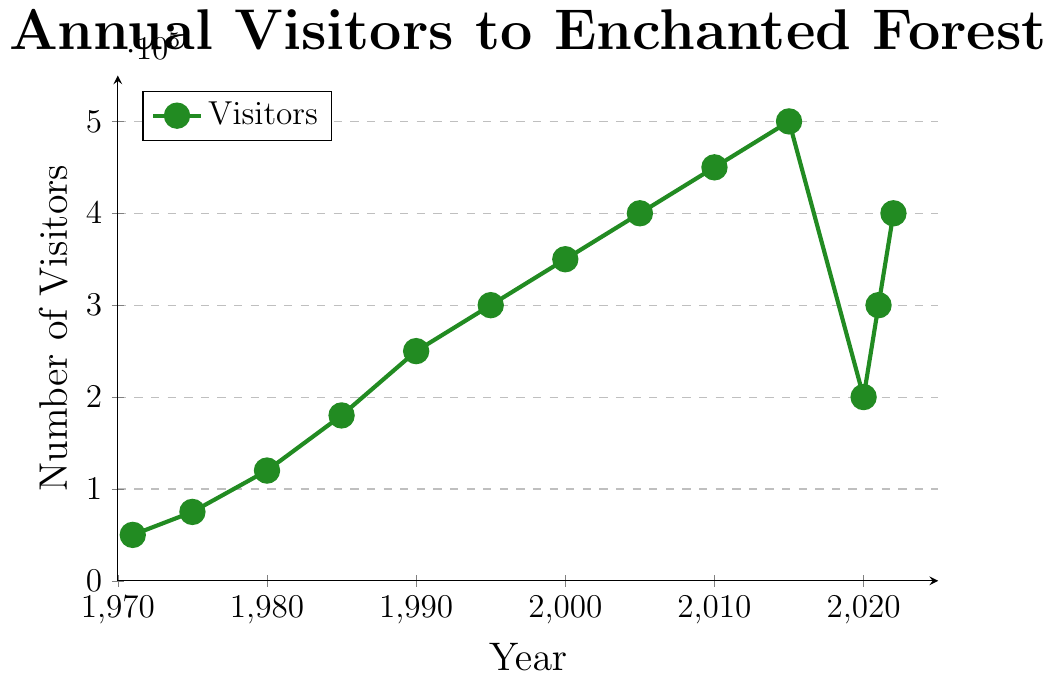What is the number of visitors in 1990? The y-axis of the chart represents the number of visitors, and the x-axis represents the years. By checking the value for 1990 on the x-axis, we trace it upwards to meet the curve, which shows a value of 250,000 on the y-axis.
Answer: 250,000 How much did the number of visitors increase between 1971 and 1985? First, find the number of visitors in 1971, which is 50,000. Next, find the number of visitors in 1985, which is 180,000. The increase is calculated by subtracting the visitors in 1971 from the visitors in 1985: 180,000 - 50,000.
Answer: 130,000 What is the average number of visitors over the years 2005, 2010, and 2015? Locate the visitor numbers for 2005 (400,000), 2010 (450,000), and 2015 (500,000). Sum these numbers: 400,000 + 450,000 + 500,000 = 1,350,000. Divide by the number of years (3): 1,350,000 / 3.
Answer: 450,000 In which year does the chart show the lowest number of visitors? To find the lowest number of visitors, look for the smallest value on the y-axis intersecting with the curve. The chart indicates this is 1971 with 50,000 visitors.
Answer: 1971 By how much did the number of visitors drop between 2015 and 2020? First, find the number of visitors in 2015, which is 500,000. Next, find the number of visitors in 2020, which is 200,000. The drop is calculated by subtracting the visitors in 2020 from the visitors in 2015: 500,000 - 200,000.
Answer: 300,000 Which year had more visitors: 1990 or 1995? Locate 1990 and 1995 on the x-axis, then see the corresponding visitor numbers on the y-axis. 1990 had 250,000 visitors and 1995 had 300,000. Since 300,000 is greater than 250,000, 1995 had more visitors.
Answer: 1995 What period experienced the largest increase in the number of visitors? Examine the chart to find the steepest slope between two consecutive years. The largest increase is between 2015 and 2020 where the slope sharply drops but rebounded sharply in 2021. However, in absolute increase over years, the period from 1971 to 1975 shows a large steep rise.
Answer: 1971 to 1975 What is the color used for marking the line plot? The line plot color can be identified visually in the chart and it is marked in green.
Answer: Green How does the visitor number in 2022 compare to 2020? Find the values for both years. In 2022, the number of visitors is 400,000, and in 2020, it is 200,000. Since 400,000 is greater than 200,000, 2022 has more visitors.
Answer: 2022 has more visitors What is the trend in visitor numbers between 2000 and 2005? Between 2000 and 2005, check the curve on the chart. The visitor numbers increased from 350,000 to 400,000, indicating an upward trend.
Answer: Upward Trend 